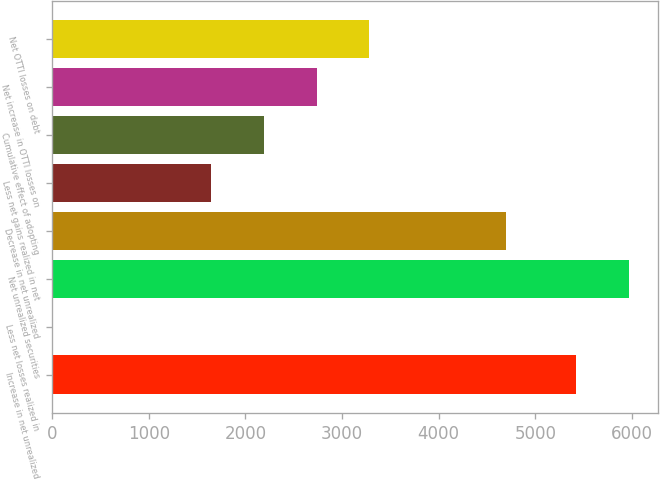<chart> <loc_0><loc_0><loc_500><loc_500><bar_chart><fcel>Increase in net unrealized<fcel>Less net losses realized in<fcel>Net unrealized securities<fcel>Decrease in net unrealized<fcel>Less net gains realized in net<fcel>Cumulative effect of adopting<fcel>Net increase in OTTI losses on<fcel>Net OTTI losses on debt<nl><fcel>5423<fcel>9<fcel>5968.8<fcel>4692<fcel>1646.4<fcel>2192.2<fcel>2738<fcel>3283.8<nl></chart> 